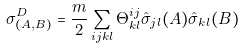Convert formula to latex. <formula><loc_0><loc_0><loc_500><loc_500>\sigma _ { ( A , B ) } ^ { D } = \frac { m } { 2 } \sum _ { i j k l } \Theta ^ { i j } _ { k l } \hat { \sigma } _ { j l } ( A ) \hat { \sigma } _ { k l } ( B )</formula> 